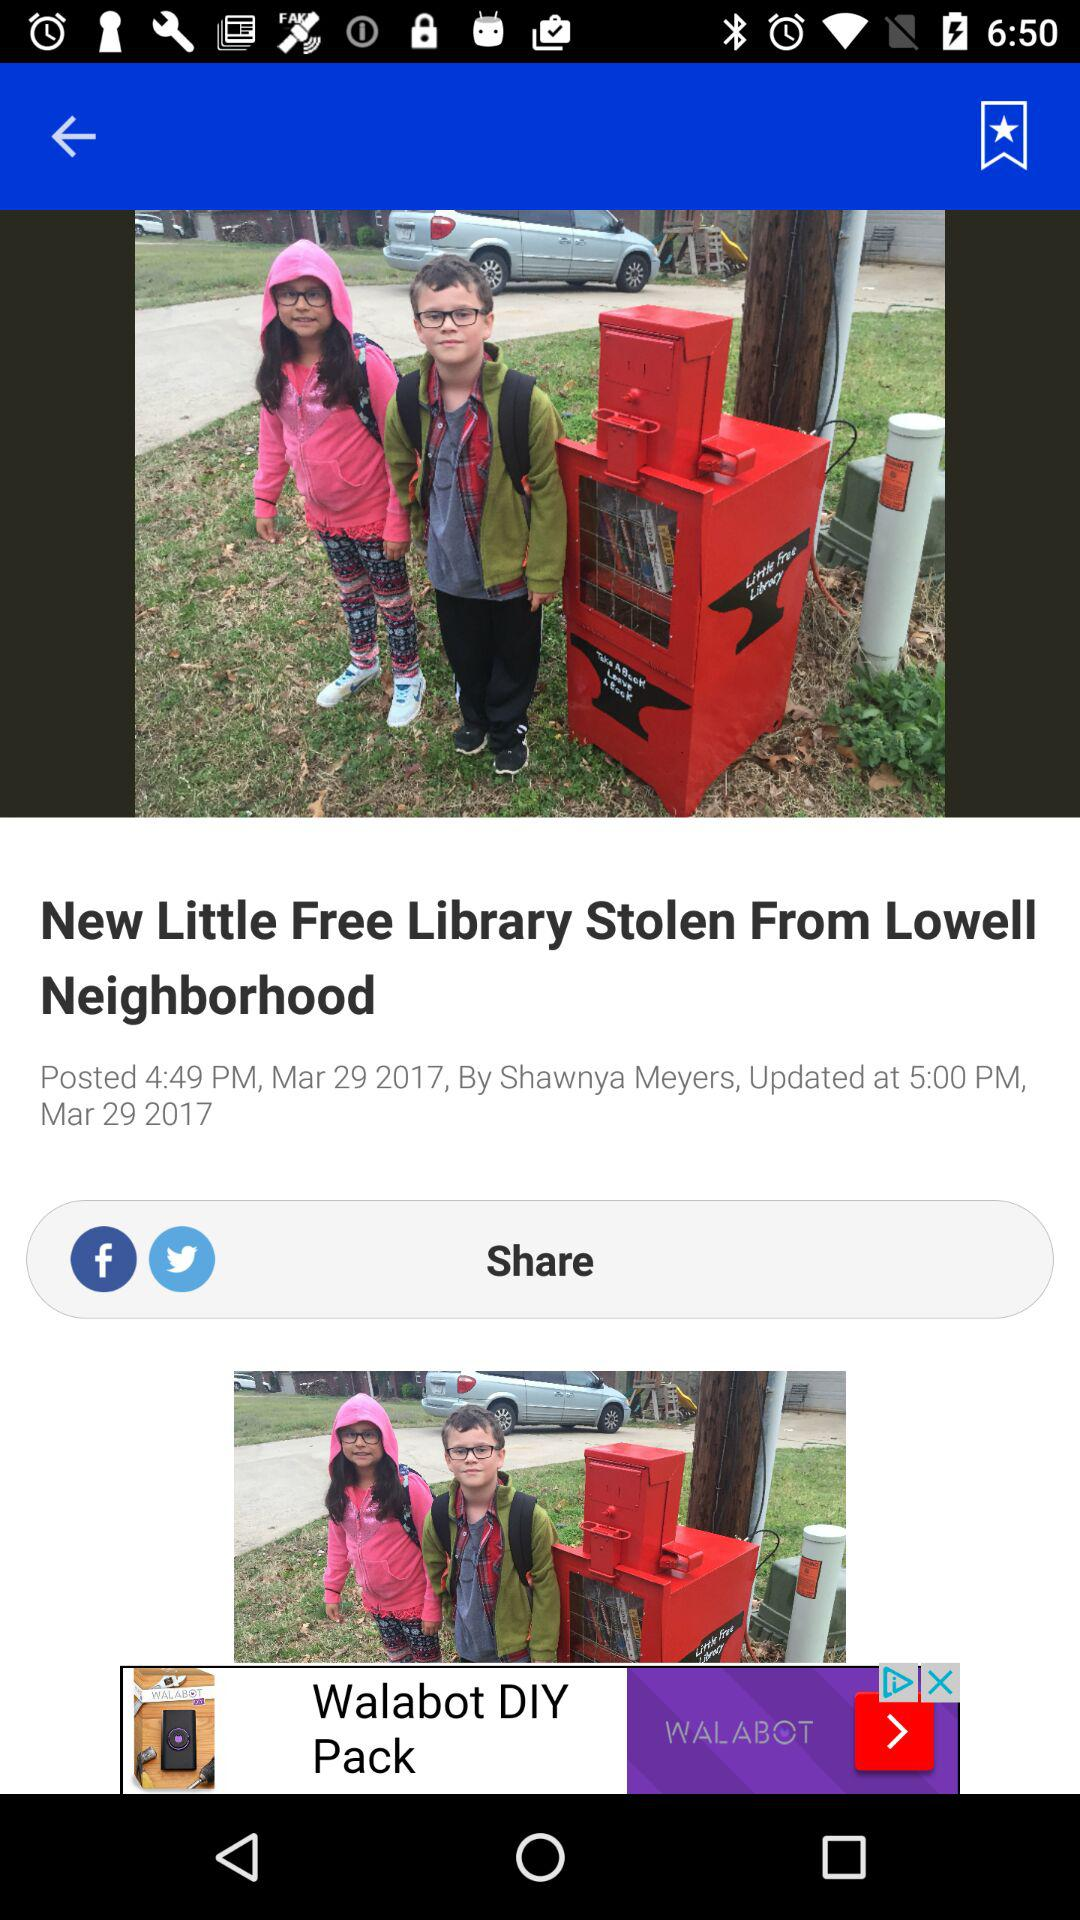With which app can we share the article? You can share the article with "Facebook" and "Twitter". 